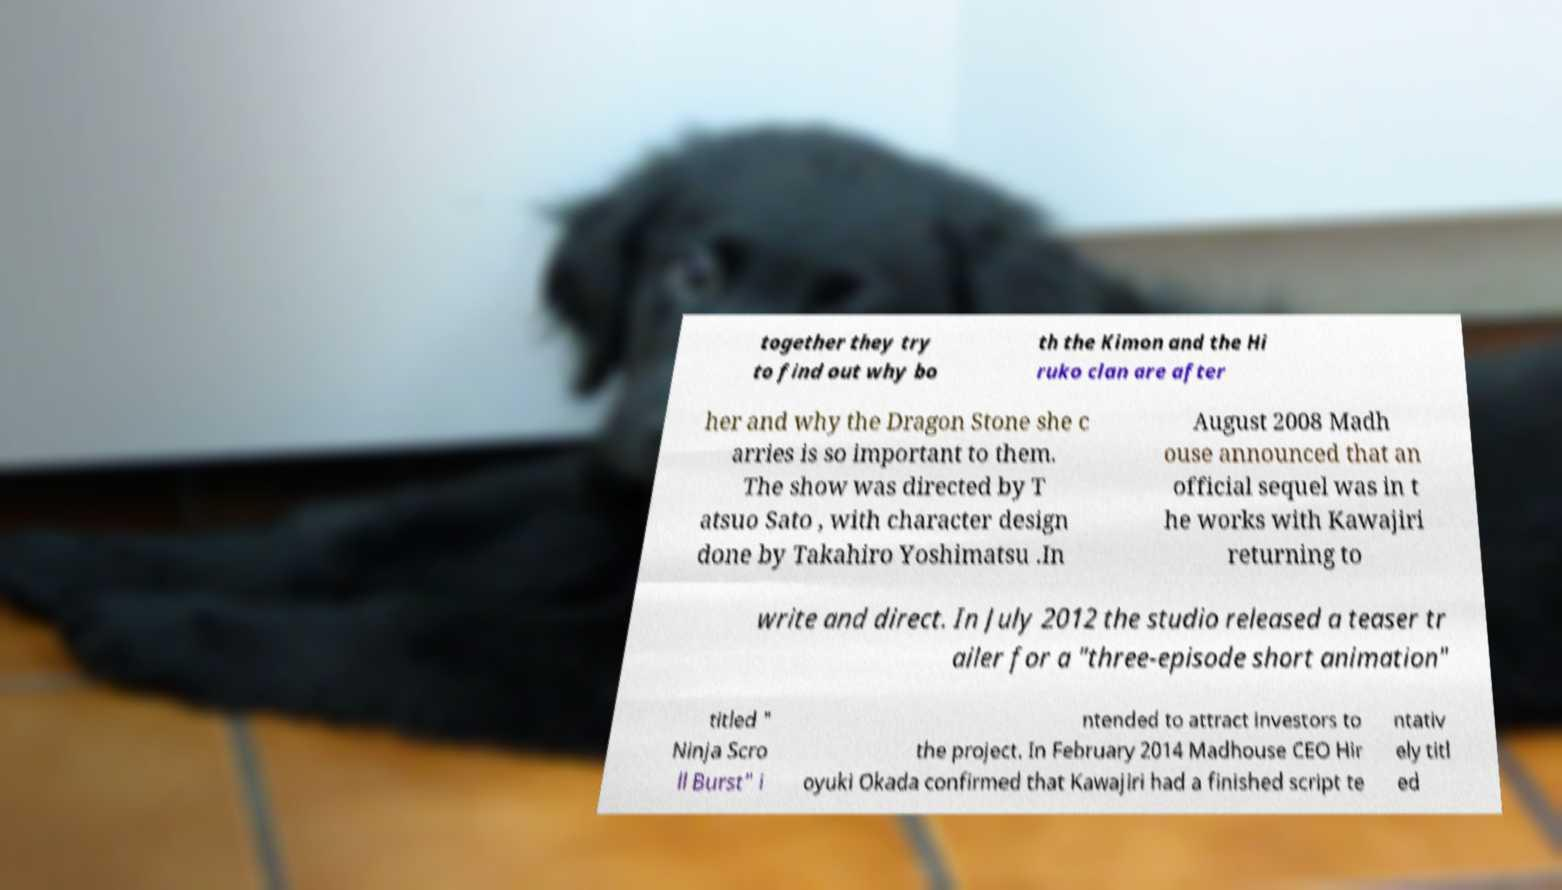Could you extract and type out the text from this image? together they try to find out why bo th the Kimon and the Hi ruko clan are after her and why the Dragon Stone she c arries is so important to them. The show was directed by T atsuo Sato , with character design done by Takahiro Yoshimatsu .In August 2008 Madh ouse announced that an official sequel was in t he works with Kawajiri returning to write and direct. In July 2012 the studio released a teaser tr ailer for a "three-episode short animation" titled " Ninja Scro ll Burst" i ntended to attract investors to the project. In February 2014 Madhouse CEO Hir oyuki Okada confirmed that Kawajiri had a finished script te ntativ ely titl ed 